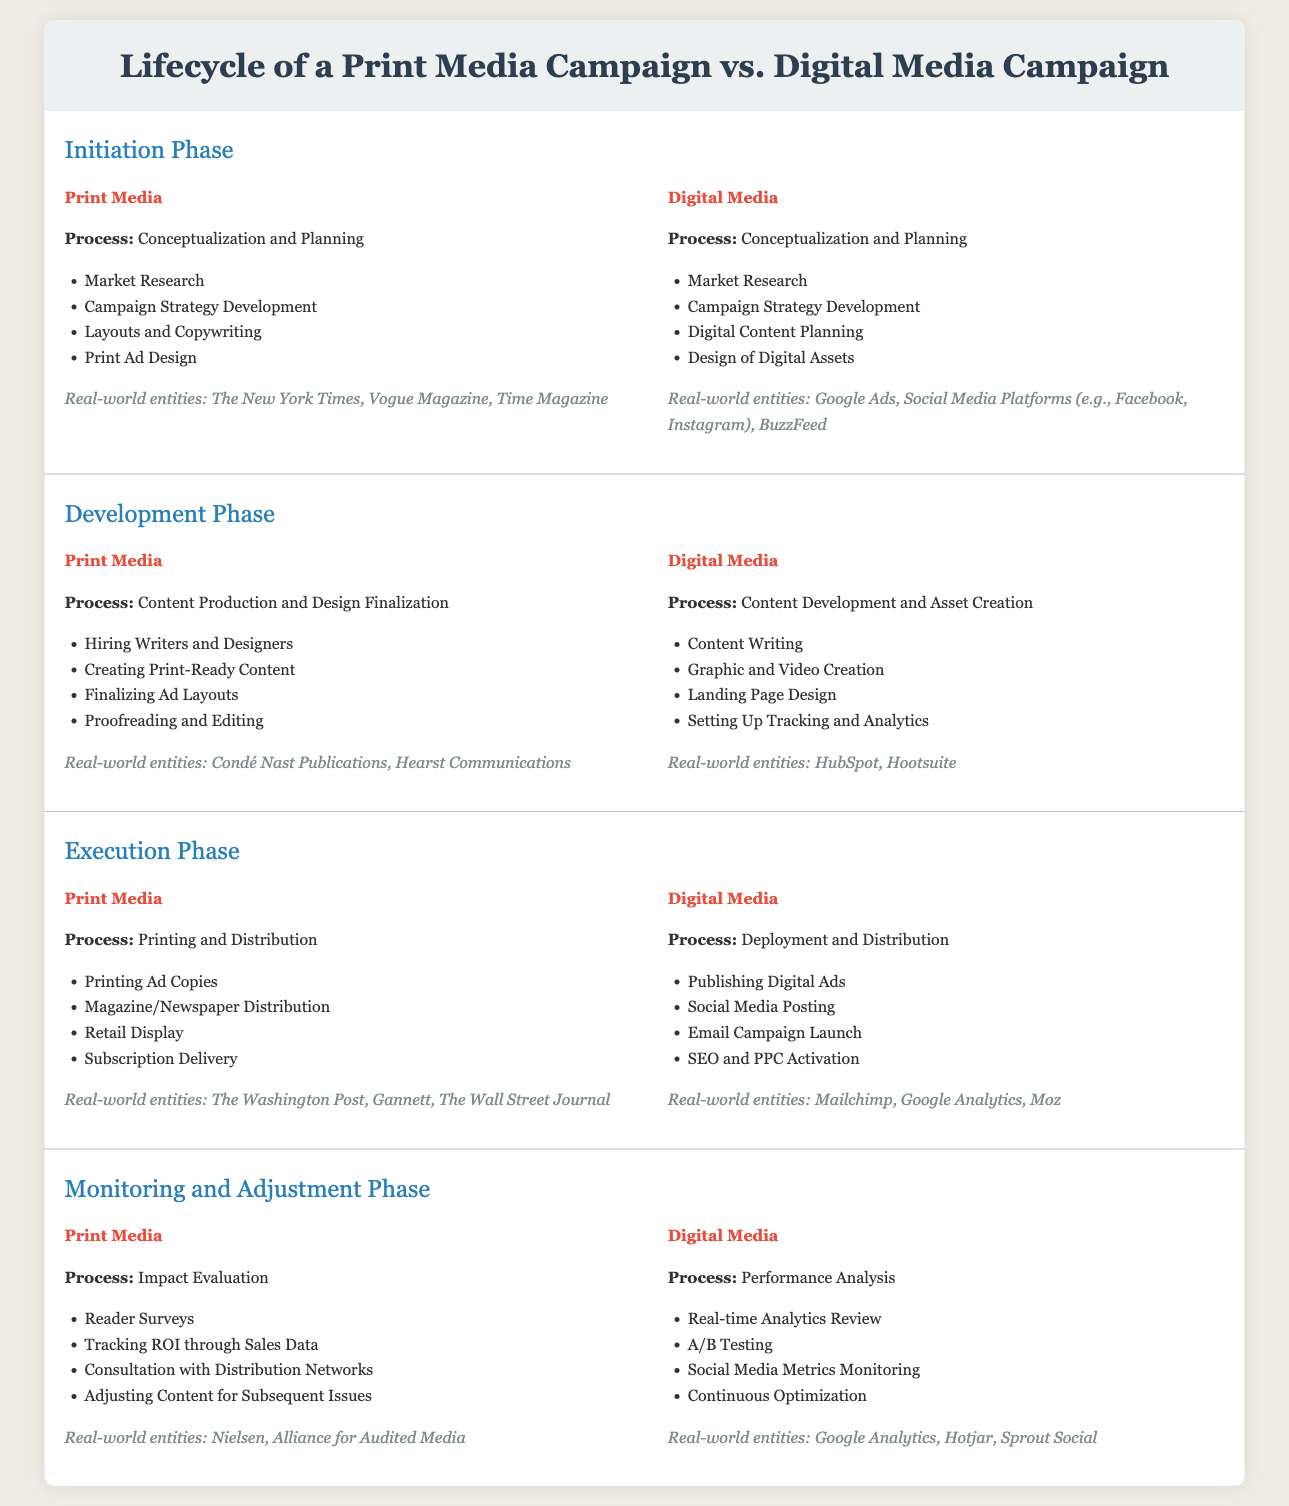What are the real-world entities mentioned for Print Media? The entities listed under Print Media include specific newspapers and magazines such as The New York Times, Vogue Magazine, and Time Magazine.
Answer: The New York Times, Vogue Magazine, Time Magazine What is the focus of the Execution Phase in Digital Media? The Execution Phase for Digital Media focuses on the Deployment and Distribution of digital advertisements and content.
Answer: Deployment and Distribution Name one process included in the Development Phase for Print Media. The Development Phase for Print Media includes several processes, one of which is Hiring Writers and Designers.
Answer: Hiring Writers and Designers What is the final step in the Monitoring and Adjustment Phase for Digital Media? The final step in the Monitoring and Adjustment Phase includes Continuous Optimization based on performance metrics.
Answer: Continuous Optimization Which phase involves Market Research for both Print and Digital Media? The Initiation Phase is common for both media types and includes Market Research as a main process.
Answer: Initiation Phase How many sections are included in the comparison infographic? The infographic contains four main sections that compare the lifecycle of Print and Digital Media campaigns.
Answer: Four In what phase do Reader Surveys occur for Print Media? Reader Surveys are part of the Monitoring and Adjustment Phase, where the impact of the campaign is evaluated.
Answer: Monitoring and Adjustment Phase What type of campaign does HubSpot relate to? HubSpot is mentioned as a real-world entity under the Digital Media section, indicating its affiliation with digital campaigns.
Answer: Digital Media What is the first step in the Initiation Phase for Digital Media? The first step in the Initiation Phase for Digital Media is Market Research, similar to that of Print Media's Initiation Phase.
Answer: Market Research 